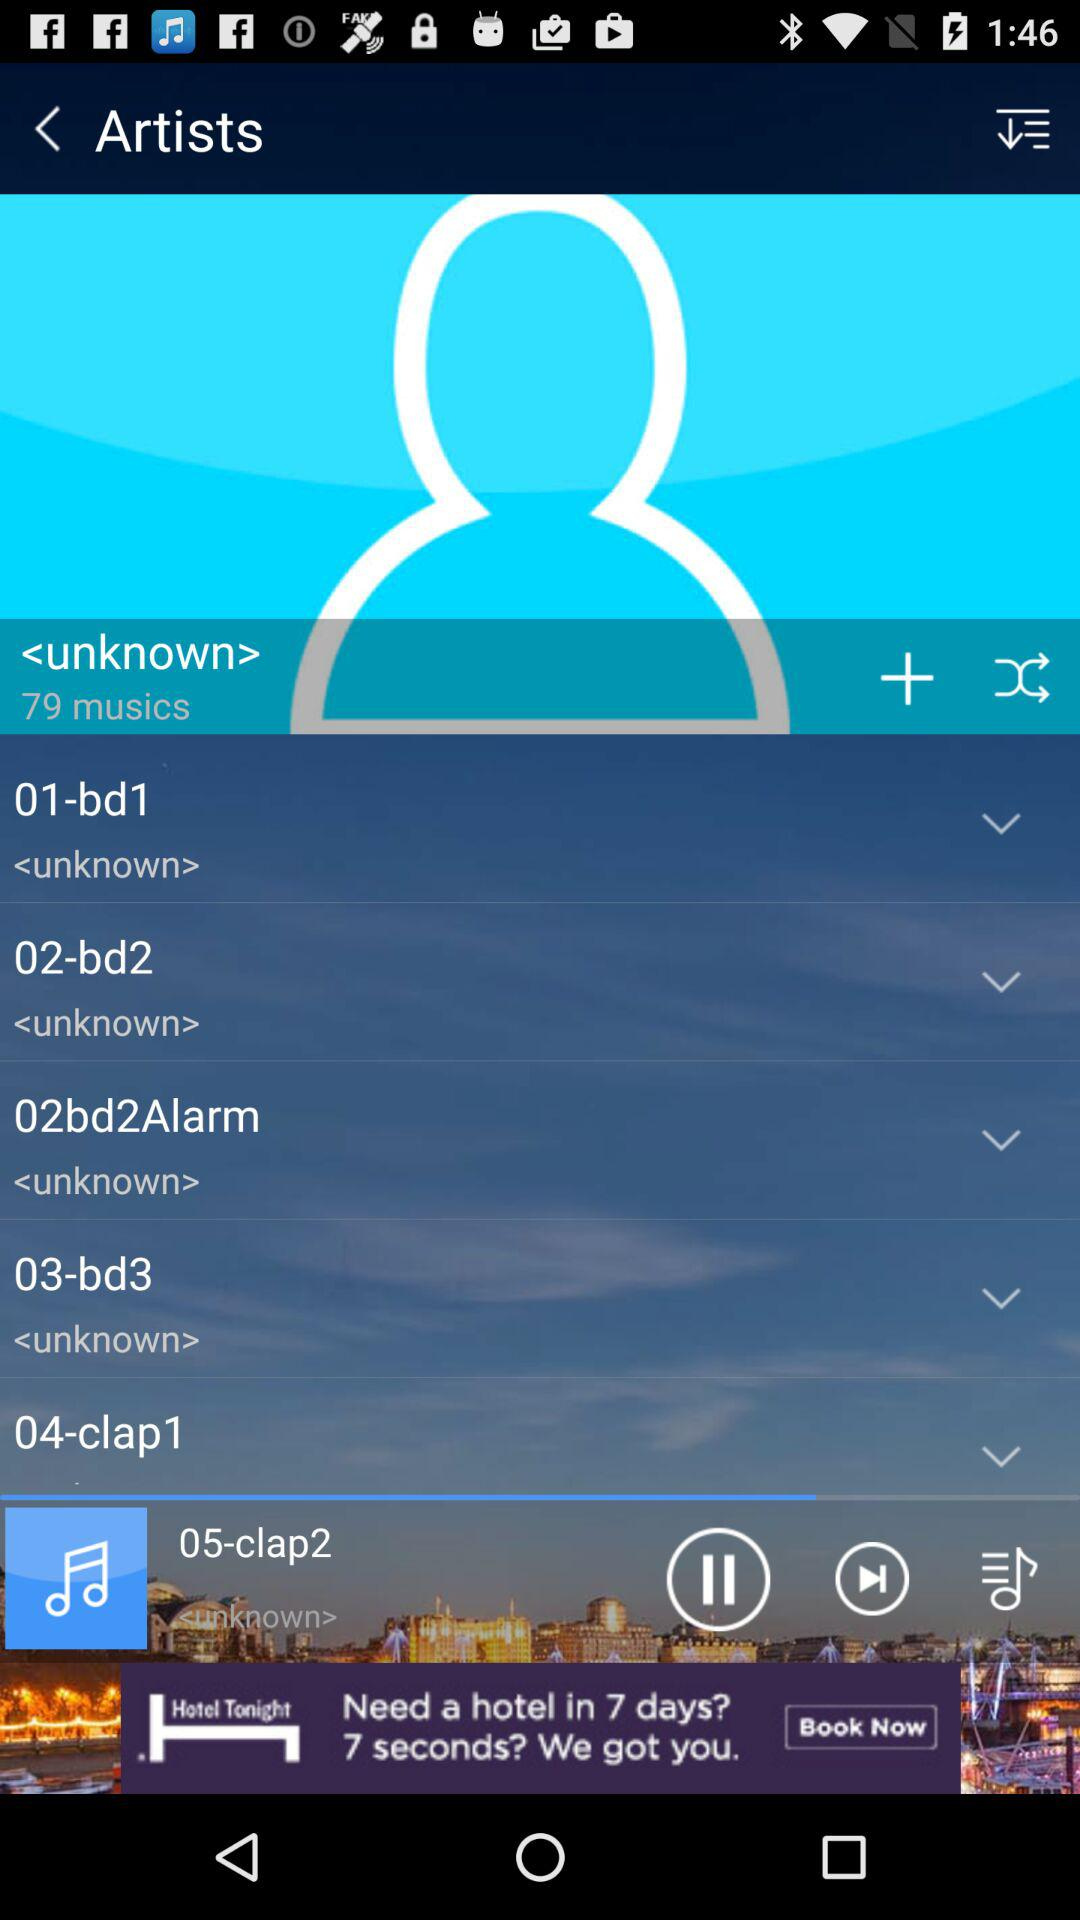How many total musics are in the unknown list? The total musics are 79. 